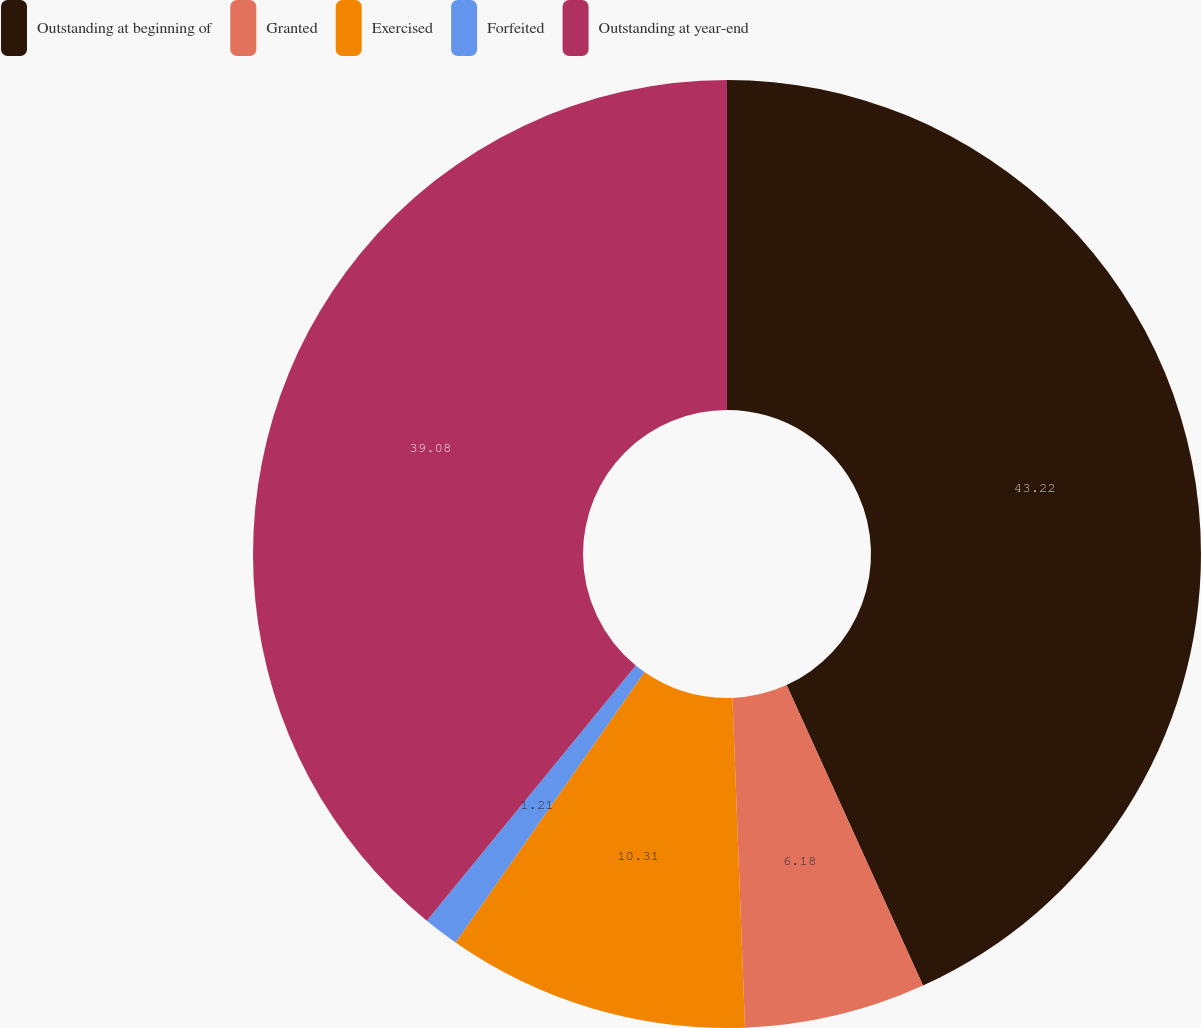Convert chart. <chart><loc_0><loc_0><loc_500><loc_500><pie_chart><fcel>Outstanding at beginning of<fcel>Granted<fcel>Exercised<fcel>Forfeited<fcel>Outstanding at year-end<nl><fcel>43.21%<fcel>6.18%<fcel>10.31%<fcel>1.21%<fcel>39.08%<nl></chart> 